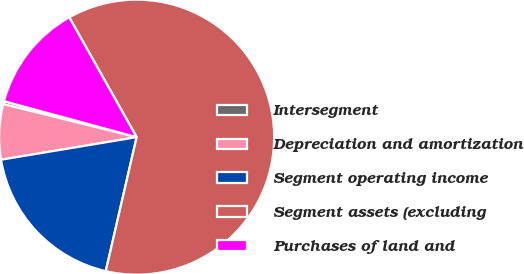Convert chart to OTSL. <chart><loc_0><loc_0><loc_500><loc_500><pie_chart><fcel>Intersegment<fcel>Depreciation and amortization<fcel>Segment operating income<fcel>Segment assets (excluding<fcel>Purchases of land and<nl><fcel>0.35%<fcel>6.49%<fcel>18.77%<fcel>61.76%<fcel>12.63%<nl></chart> 